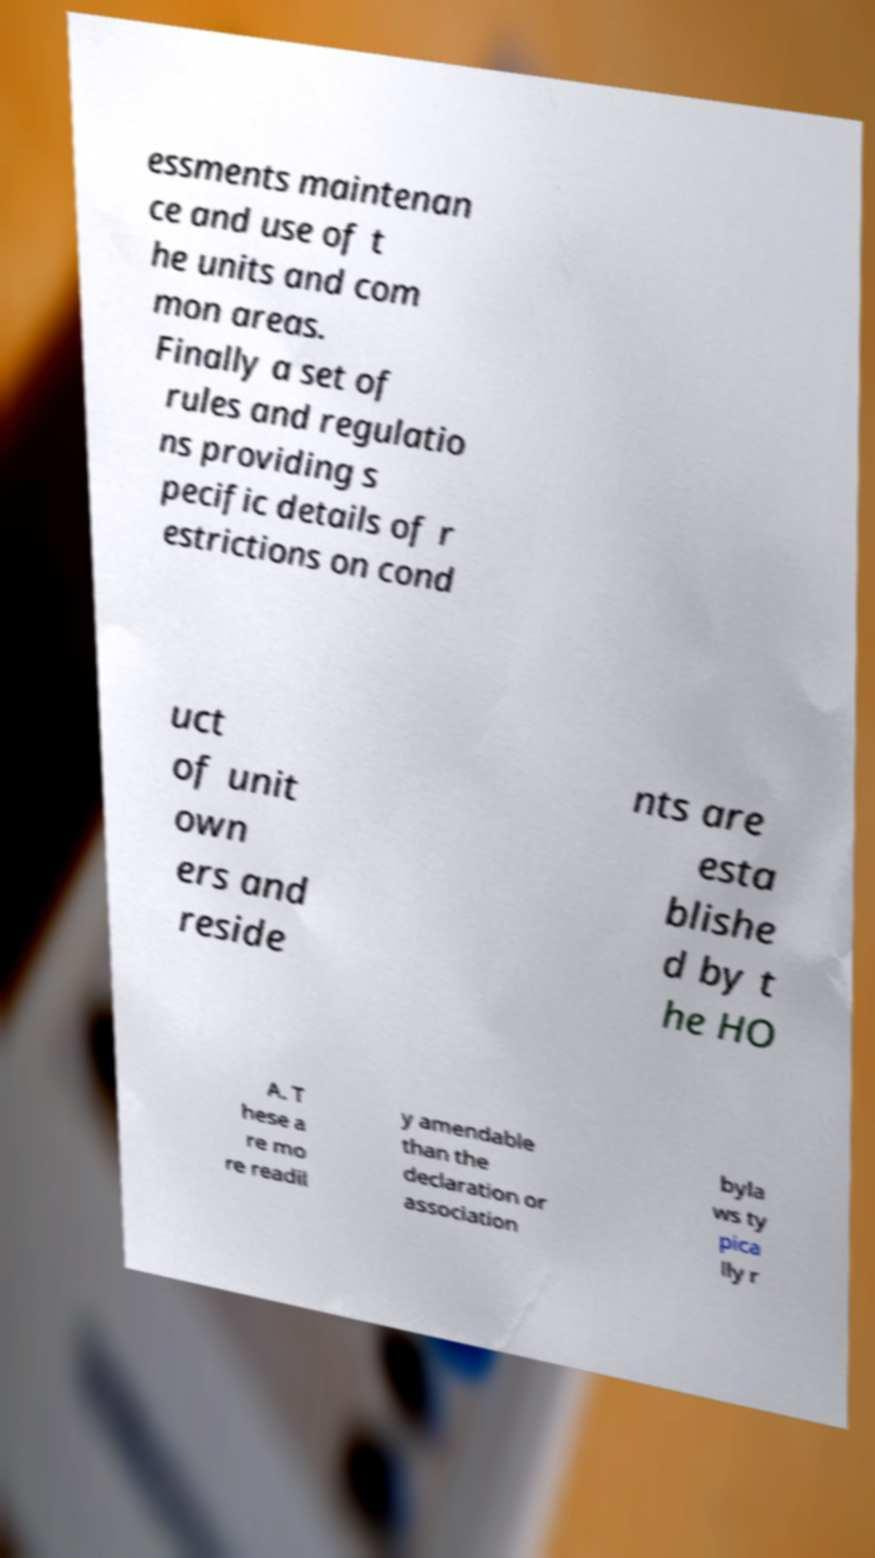Please identify and transcribe the text found in this image. essments maintenan ce and use of t he units and com mon areas. Finally a set of rules and regulatio ns providing s pecific details of r estrictions on cond uct of unit own ers and reside nts are esta blishe d by t he HO A. T hese a re mo re readil y amendable than the declaration or association byla ws ty pica lly r 